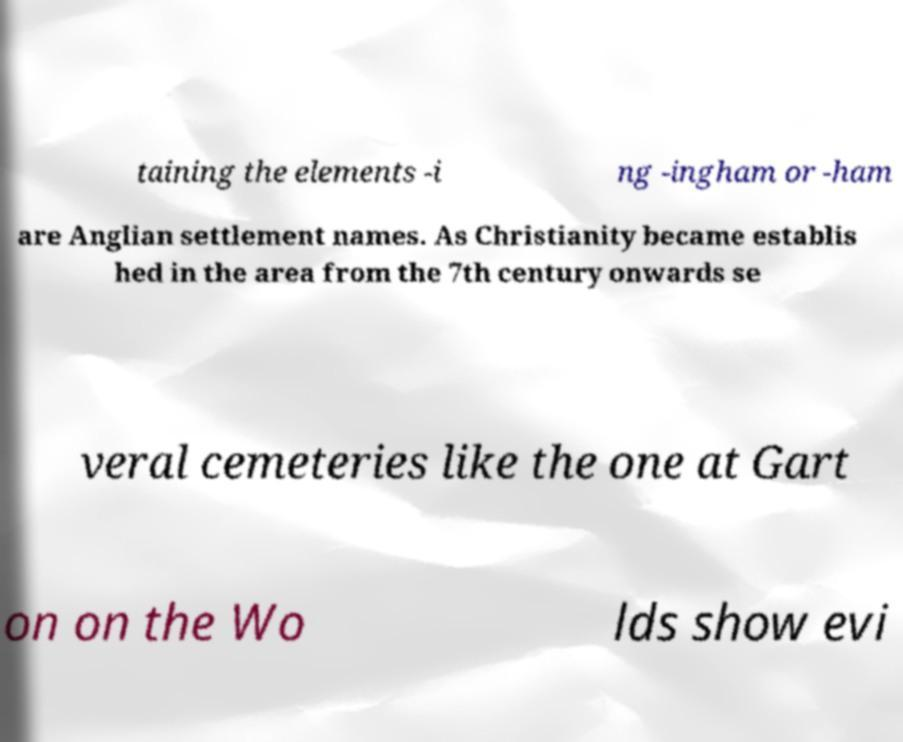For documentation purposes, I need the text within this image transcribed. Could you provide that? taining the elements -i ng -ingham or -ham are Anglian settlement names. As Christianity became establis hed in the area from the 7th century onwards se veral cemeteries like the one at Gart on on the Wo lds show evi 